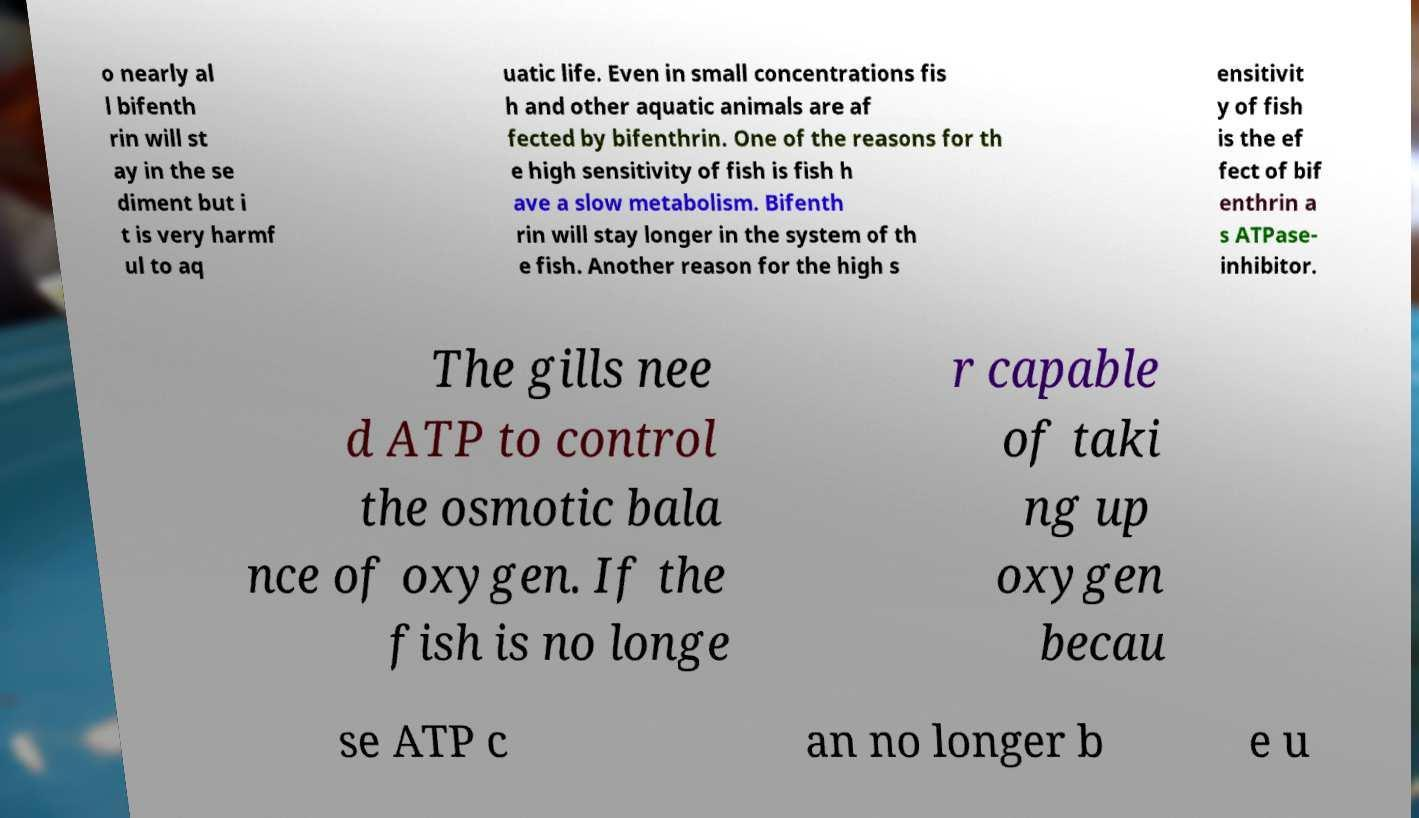For documentation purposes, I need the text within this image transcribed. Could you provide that? o nearly al l bifenth rin will st ay in the se diment but i t is very harmf ul to aq uatic life. Even in small concentrations fis h and other aquatic animals are af fected by bifenthrin. One of the reasons for th e high sensitivity of fish is fish h ave a slow metabolism. Bifenth rin will stay longer in the system of th e fish. Another reason for the high s ensitivit y of fish is the ef fect of bif enthrin a s ATPase- inhibitor. The gills nee d ATP to control the osmotic bala nce of oxygen. If the fish is no longe r capable of taki ng up oxygen becau se ATP c an no longer b e u 